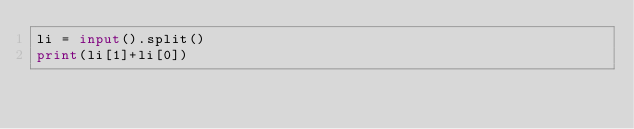Convert code to text. <code><loc_0><loc_0><loc_500><loc_500><_Python_>li = input().split()
print(li[1]+li[0])</code> 